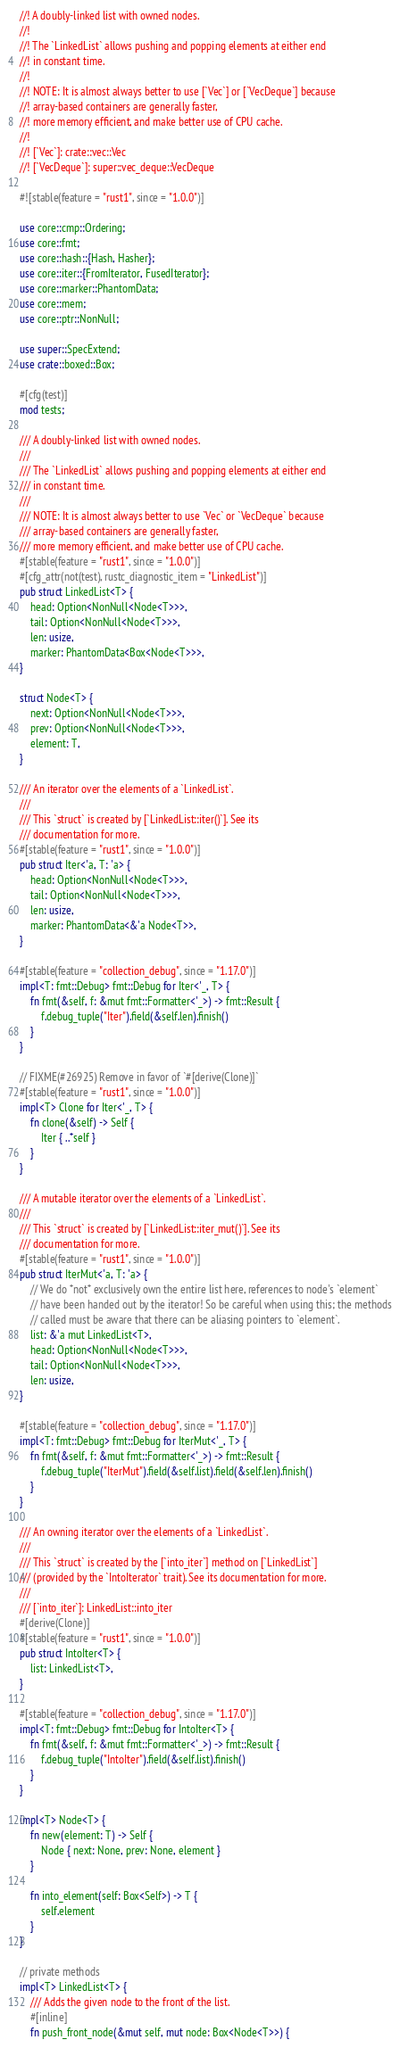<code> <loc_0><loc_0><loc_500><loc_500><_Rust_>//! A doubly-linked list with owned nodes.
//!
//! The `LinkedList` allows pushing and popping elements at either end
//! in constant time.
//!
//! NOTE: It is almost always better to use [`Vec`] or [`VecDeque`] because
//! array-based containers are generally faster,
//! more memory efficient, and make better use of CPU cache.
//!
//! [`Vec`]: crate::vec::Vec
//! [`VecDeque`]: super::vec_deque::VecDeque

#![stable(feature = "rust1", since = "1.0.0")]

use core::cmp::Ordering;
use core::fmt;
use core::hash::{Hash, Hasher};
use core::iter::{FromIterator, FusedIterator};
use core::marker::PhantomData;
use core::mem;
use core::ptr::NonNull;

use super::SpecExtend;
use crate::boxed::Box;

#[cfg(test)]
mod tests;

/// A doubly-linked list with owned nodes.
///
/// The `LinkedList` allows pushing and popping elements at either end
/// in constant time.
///
/// NOTE: It is almost always better to use `Vec` or `VecDeque` because
/// array-based containers are generally faster,
/// more memory efficient, and make better use of CPU cache.
#[stable(feature = "rust1", since = "1.0.0")]
#[cfg_attr(not(test), rustc_diagnostic_item = "LinkedList")]
pub struct LinkedList<T> {
    head: Option<NonNull<Node<T>>>,
    tail: Option<NonNull<Node<T>>>,
    len: usize,
    marker: PhantomData<Box<Node<T>>>,
}

struct Node<T> {
    next: Option<NonNull<Node<T>>>,
    prev: Option<NonNull<Node<T>>>,
    element: T,
}

/// An iterator over the elements of a `LinkedList`.
///
/// This `struct` is created by [`LinkedList::iter()`]. See its
/// documentation for more.
#[stable(feature = "rust1", since = "1.0.0")]
pub struct Iter<'a, T: 'a> {
    head: Option<NonNull<Node<T>>>,
    tail: Option<NonNull<Node<T>>>,
    len: usize,
    marker: PhantomData<&'a Node<T>>,
}

#[stable(feature = "collection_debug", since = "1.17.0")]
impl<T: fmt::Debug> fmt::Debug for Iter<'_, T> {
    fn fmt(&self, f: &mut fmt::Formatter<'_>) -> fmt::Result {
        f.debug_tuple("Iter").field(&self.len).finish()
    }
}

// FIXME(#26925) Remove in favor of `#[derive(Clone)]`
#[stable(feature = "rust1", since = "1.0.0")]
impl<T> Clone for Iter<'_, T> {
    fn clone(&self) -> Self {
        Iter { ..*self }
    }
}

/// A mutable iterator over the elements of a `LinkedList`.
///
/// This `struct` is created by [`LinkedList::iter_mut()`]. See its
/// documentation for more.
#[stable(feature = "rust1", since = "1.0.0")]
pub struct IterMut<'a, T: 'a> {
    // We do *not* exclusively own the entire list here, references to node's `element`
    // have been handed out by the iterator! So be careful when using this; the methods
    // called must be aware that there can be aliasing pointers to `element`.
    list: &'a mut LinkedList<T>,
    head: Option<NonNull<Node<T>>>,
    tail: Option<NonNull<Node<T>>>,
    len: usize,
}

#[stable(feature = "collection_debug", since = "1.17.0")]
impl<T: fmt::Debug> fmt::Debug for IterMut<'_, T> {
    fn fmt(&self, f: &mut fmt::Formatter<'_>) -> fmt::Result {
        f.debug_tuple("IterMut").field(&self.list).field(&self.len).finish()
    }
}

/// An owning iterator over the elements of a `LinkedList`.
///
/// This `struct` is created by the [`into_iter`] method on [`LinkedList`]
/// (provided by the `IntoIterator` trait). See its documentation for more.
///
/// [`into_iter`]: LinkedList::into_iter
#[derive(Clone)]
#[stable(feature = "rust1", since = "1.0.0")]
pub struct IntoIter<T> {
    list: LinkedList<T>,
}

#[stable(feature = "collection_debug", since = "1.17.0")]
impl<T: fmt::Debug> fmt::Debug for IntoIter<T> {
    fn fmt(&self, f: &mut fmt::Formatter<'_>) -> fmt::Result {
        f.debug_tuple("IntoIter").field(&self.list).finish()
    }
}

impl<T> Node<T> {
    fn new(element: T) -> Self {
        Node { next: None, prev: None, element }
    }

    fn into_element(self: Box<Self>) -> T {
        self.element
    }
}

// private methods
impl<T> LinkedList<T> {
    /// Adds the given node to the front of the list.
    #[inline]
    fn push_front_node(&mut self, mut node: Box<Node<T>>) {</code> 